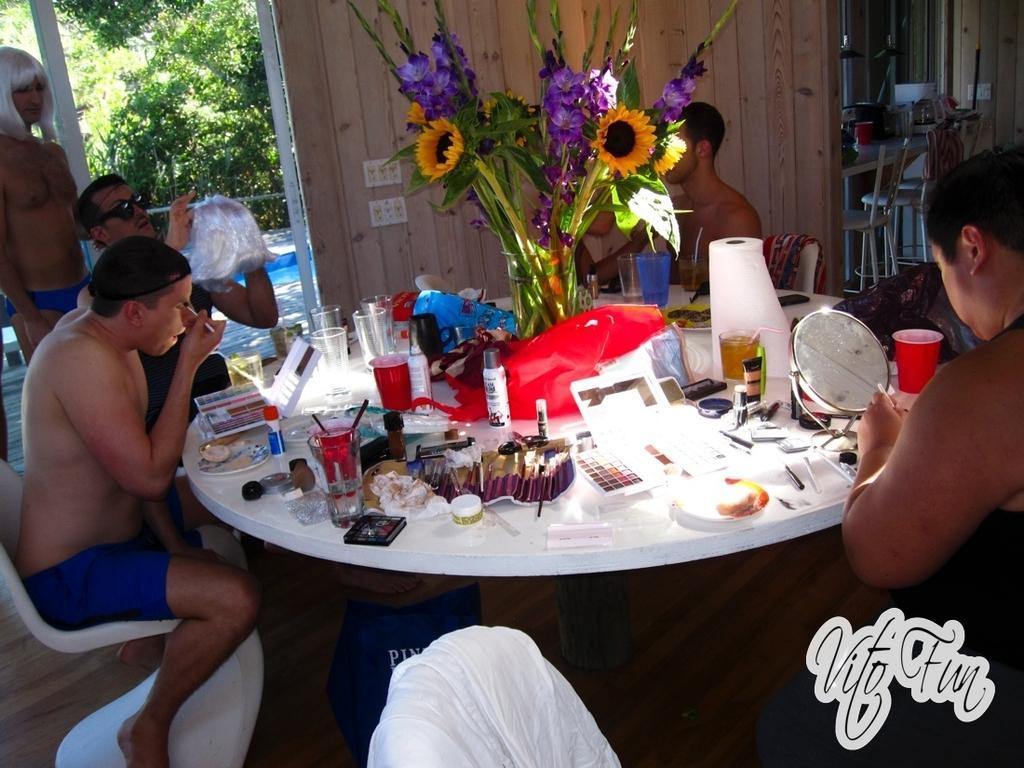Could you give a brief overview of what you see in this image? Here we can see that a group of people sitting on the chair, and in front here is the table, and flower vase and glasses and many other objects on it, and here is the glass, and here is the tree. 